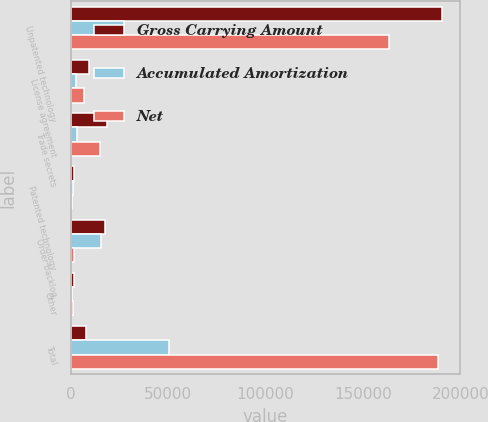Convert chart to OTSL. <chart><loc_0><loc_0><loc_500><loc_500><stacked_bar_chart><ecel><fcel>Unpatented technology<fcel>License agreement<fcel>Trade secrets<fcel>Patented technology<fcel>Order backlog<fcel>Other<fcel>Total<nl><fcel>Gross Carrying Amount<fcel>190493<fcel>9373<fcel>18462<fcel>1670<fcel>17520<fcel>1600<fcel>8002.5<nl><fcel>Accumulated Amortization<fcel>27180<fcel>2741<fcel>3267<fcel>922<fcel>15698<fcel>742<fcel>50550<nl><fcel>Net<fcel>163313<fcel>6632<fcel>15195<fcel>748<fcel>1822<fcel>858<fcel>188568<nl></chart> 